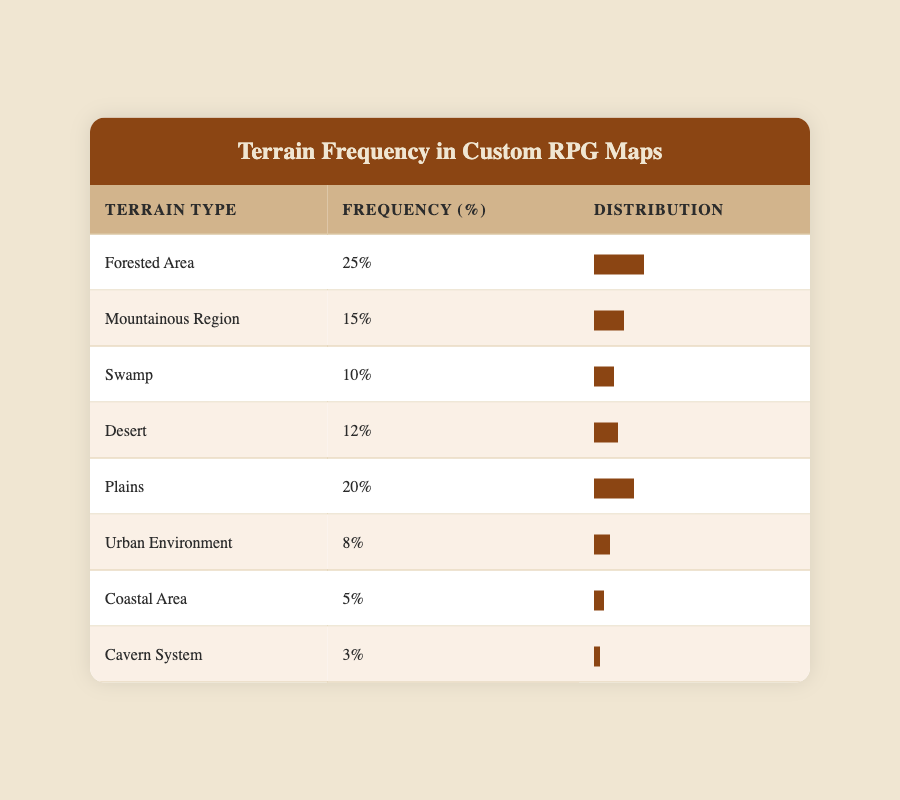What is the frequency of the Forested Area? The frequency is listed directly in the table next to the Forested Area, which states 25%.
Answer: 25% What is the total frequency of all terrain types? To find the total frequency, add all the individual frequencies: 25 + 15 + 10 + 12 + 20 + 8 + 5 + 3 = 108.
Answer: 108 Is the frequency of the Urban Environment greater than that of the Coastal Area? The frequency of Urban Environment is 8% and for Coastal Area is 5%. Since 8% is greater than 5%, the statement is true.
Answer: Yes What percentage of the total frequency do the Swamp and Desert terrains combine for? Adding the frequencies of Swamp (10%) and Desert (12%) gives 10 + 12 = 22%.
Answer: 22% What is the median frequency of the terrain types listed? To find the median, first list the frequencies: 3, 5, 8, 10, 12, 15, 20, 25. There are 8 values, so the median will be the average of the 4th and 5th values: (10 + 12) / 2 = 11.
Answer: 11 How many terrain types have a frequency of 15% or higher? By examining the table, the terrain types with frequencies of 15% or higher are Forested Area (25%), Mountainous Region (15%), Plains (20%), and Desert (12%). Counting these gives a total of 4 terrain types.
Answer: 4 What is the difference in frequency between the Forested Area and the Cavern System? The frequency of the Forested Area is 25% and for the Cavern System it is 3%. The difference is calculated as 25 - 3 = 22%.
Answer: 22% Which terrain type has the lowest frequency? By scanning the frequency values in the table, the Cavern System has the lowest frequency at 3%.
Answer: Cavern System 